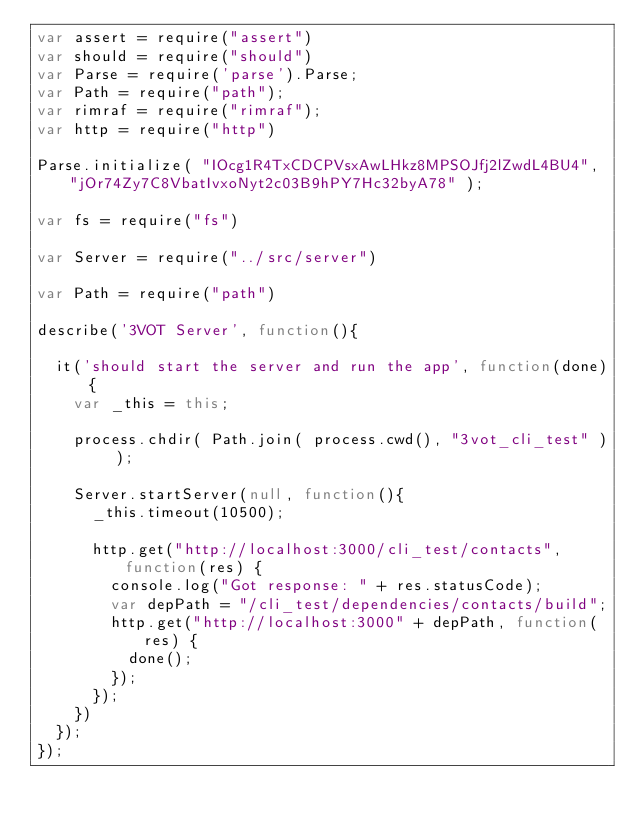<code> <loc_0><loc_0><loc_500><loc_500><_JavaScript_>var assert = require("assert")
var should = require("should")
var Parse = require('parse').Parse;
var Path = require("path");
var rimraf = require("rimraf");
var http = require("http")

Parse.initialize( "IOcg1R4TxCDCPVsxAwLHkz8MPSOJfj2lZwdL4BU4", "jOr74Zy7C8VbatIvxoNyt2c03B9hPY7Hc32byA78" );

var fs = require("fs")

var Server = require("../src/server")

var Path = require("path")

describe('3VOT Server', function(){
  
  it('should start the server and run the app', function(done){
    var _this = this;
    
    process.chdir( Path.join( process.cwd(), "3vot_cli_test" ) );
    
    Server.startServer(null, function(){
      _this.timeout(10500);
      
      http.get("http://localhost:3000/cli_test/contacts", function(res) {
        console.log("Got response: " + res.statusCode);
        var depPath = "/cli_test/dependencies/contacts/build";
        http.get("http://localhost:3000" + depPath, function(res) {
          done();
        });
      });
    })
  });
});</code> 